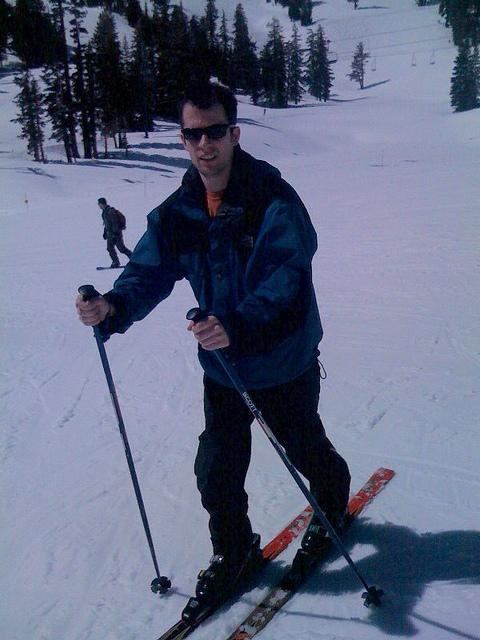What is the man in the foreground balancing with? ski poles 